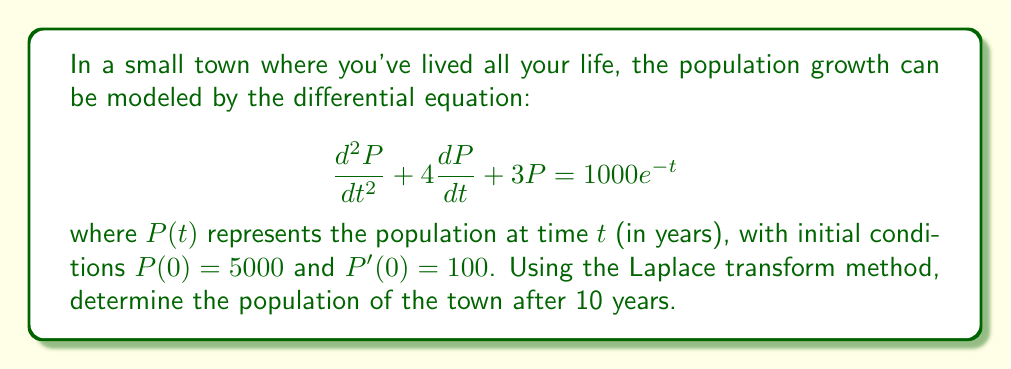Help me with this question. Let's solve this step-by-step using the Laplace transform method:

1) First, we take the Laplace transform of both sides of the equation:

   $\mathcal{L}\{P''(t) + 4P'(t) + 3P(t)\} = \mathcal{L}\{1000e^{-t}\}$

2) Using the properties of Laplace transforms:

   $(s^2\mathcal{L}\{P(t)\} - sP(0) - P'(0)) + 4(s\mathcal{L}\{P(t)\} - P(0)) + 3\mathcal{L}\{P(t)\} = \frac{1000}{s+1}$

3) Let $\mathcal{L}\{P(t)\} = X(s)$. Substituting the initial conditions:

   $(s^2X(s) - 5000s - 100) + 4(sX(s) - 5000) + 3X(s) = \frac{1000}{s+1}$

4) Simplify:

   $s^2X(s) + 4sX(s) + 3X(s) = 5000s + 20100 + \frac{1000}{s+1}$

   $(s^2 + 4s + 3)X(s) = 5000s + 20100 + \frac{1000}{s+1}$

5) Solve for $X(s)$:

   $X(s) = \frac{5000s + 20100 + \frac{1000}{s+1}}{s^2 + 4s + 3}$

6) Simplify the fraction:

   $X(s) = \frac{5000s(s+1) + 20100(s+1) + 1000}{(s^2 + 4s + 3)(s+1)}$
   
   $X(s) = \frac{5000s^2 + 25100s + 20100}{(s^2 + 4s + 3)(s+1)}$

7) Use partial fraction decomposition:

   $X(s) = \frac{A}{s+1} + \frac{B}{s+3} + \frac{C}{s}$

   Solving for A, B, and C (details omitted for brevity):
   
   $A = 5000, B = -1000, C = 6700$

8) Now we can write:

   $X(s) = \frac{5000}{s+1} - \frac{1000}{s+3} + \frac{6700}{s}$

9) Take the inverse Laplace transform:

   $P(t) = 5000e^{-t} - 1000e^{-3t} + 6700$

10) To find the population after 10 years, substitute $t = 10$:

    $P(10) = 5000e^{-10} - 1000e^{-30} + 6700$
Answer: $P(10) \approx 6723$ people (rounded to the nearest whole number) 